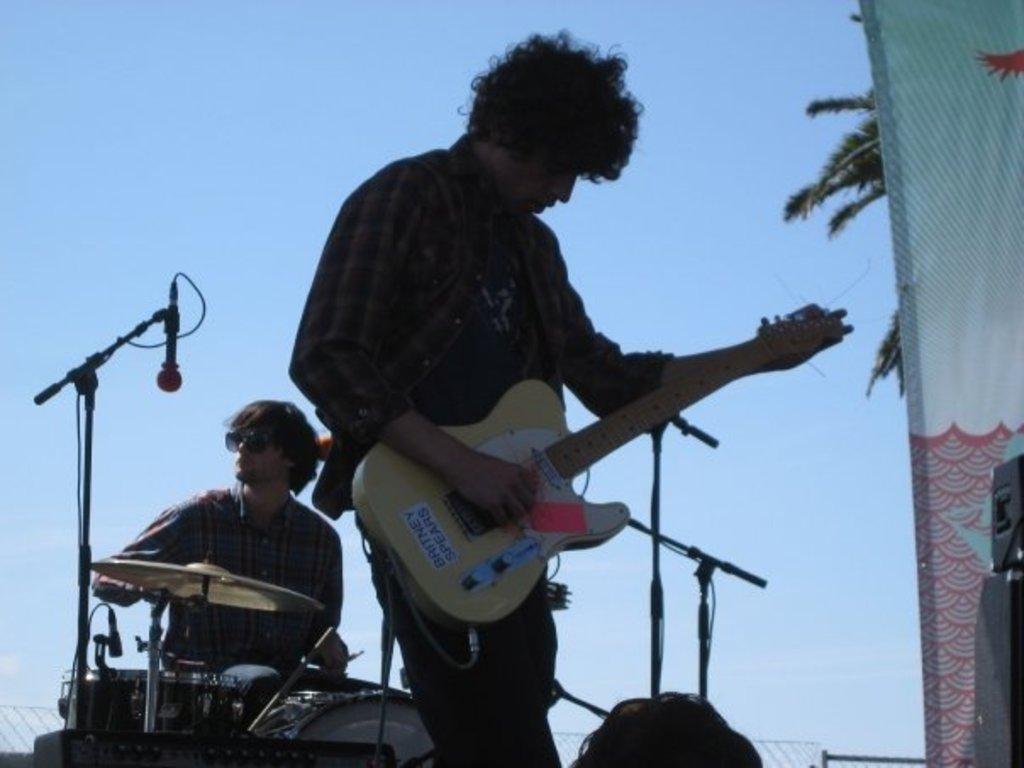Please provide a concise description of this image. This is a picture taken in the outdoor, there are the two persons on the stage performing the music instruments. Background of this two people is sky. 